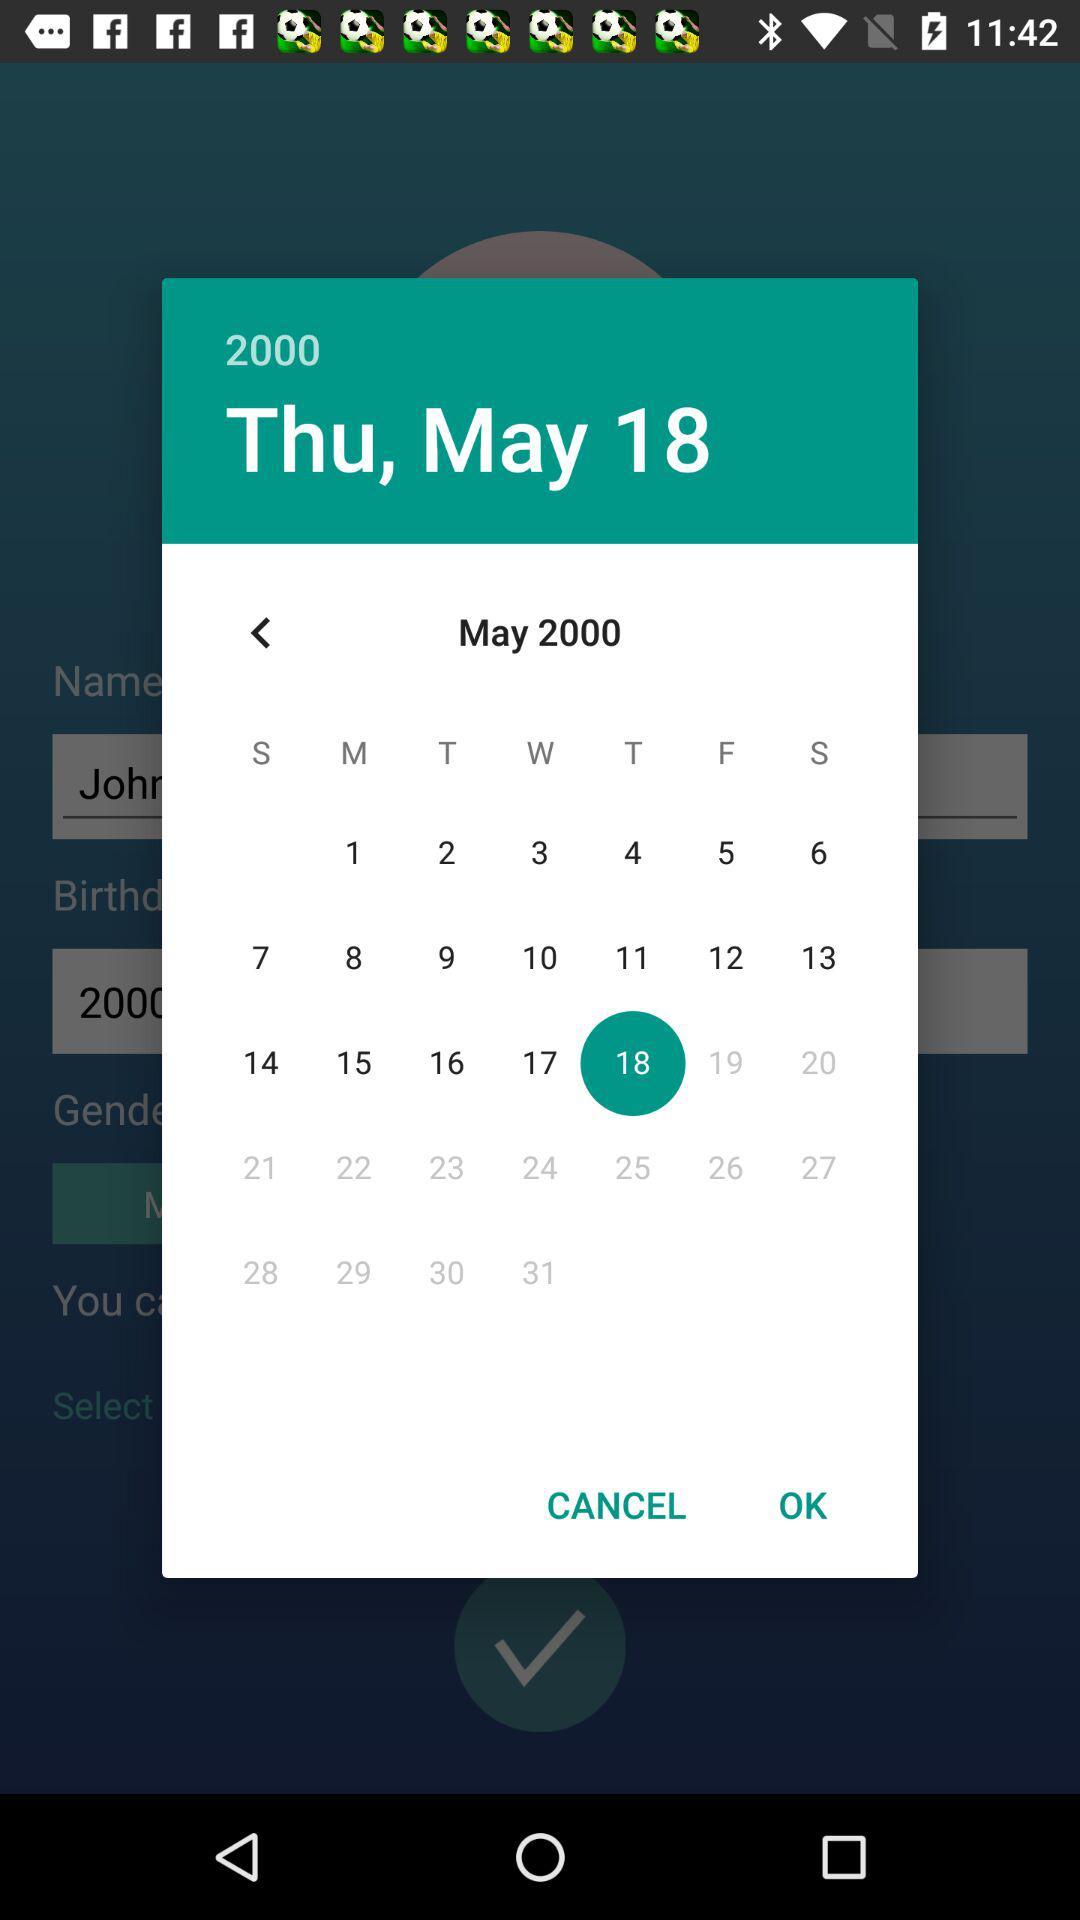What is the day on May 18, 2000? The day is Thursday. 